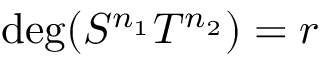<formula> <loc_0><loc_0><loc_500><loc_500>d e g ( S ^ { n _ { 1 } } T ^ { n _ { 2 } } ) = r</formula> 